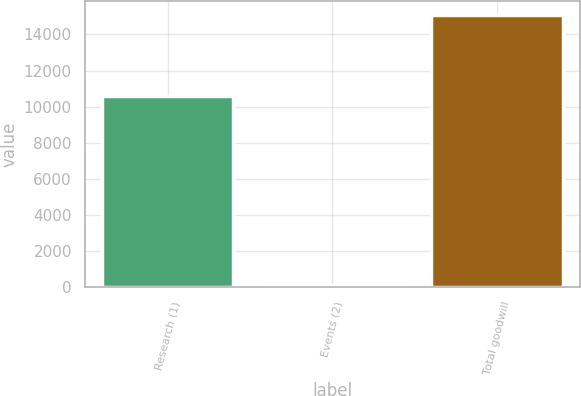Convert chart. <chart><loc_0><loc_0><loc_500><loc_500><bar_chart><fcel>Research (1)<fcel>Events (2)<fcel>Total goodwill<nl><fcel>10600<fcel>107<fcel>15084<nl></chart> 